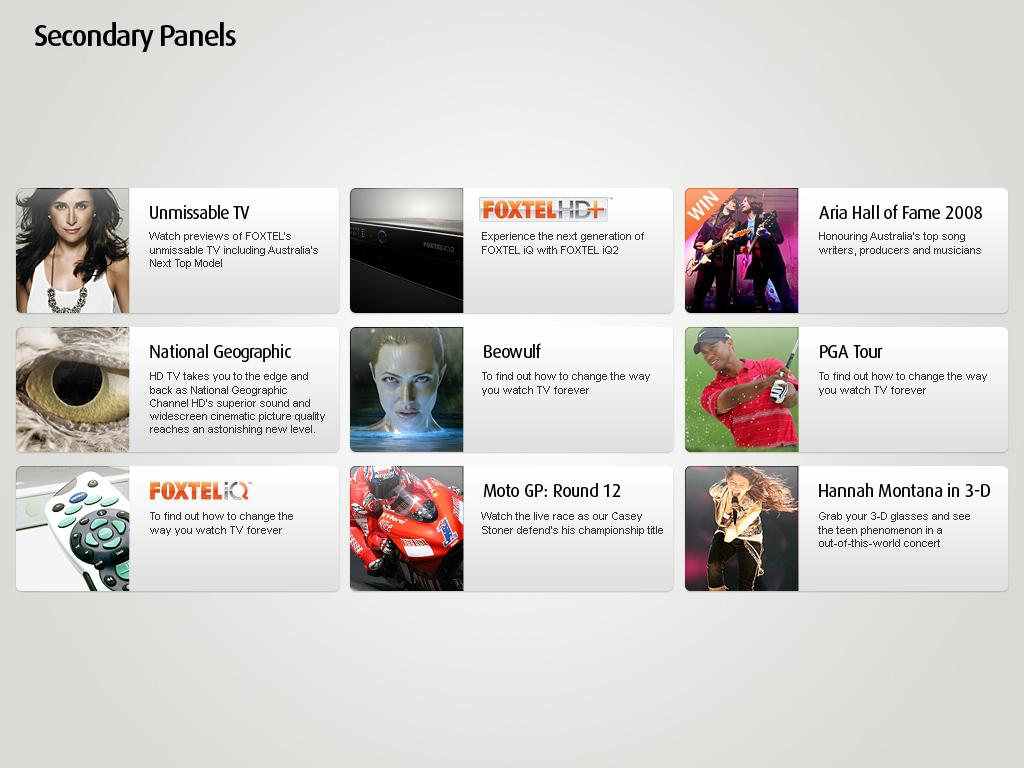What type of device is the main subject of the image? The image appears to be a TV screen. Can you describe the people in the image? There are people in the image, but their specific actions or appearances are not mentioned in the facts. What is written in the image? There is text in the image, and it is located at the top of the image. What object is used for controlling the TV? A remote is visible in the image. What mode of transportation is present in the image? A bike is present in the image. What body part is depicted in the image? An eye is depicted in the image. Are there any other objects in the image besides those mentioned? Yes, there are other objects in the image, but their specific details are not mentioned in the facts. What type of zinc is being used to create the text in the image? There is no mention of zinc in the image or the facts provided. What is the profit margin for the items shown in the image? There is no information about profit margins in the image or the facts provided. 